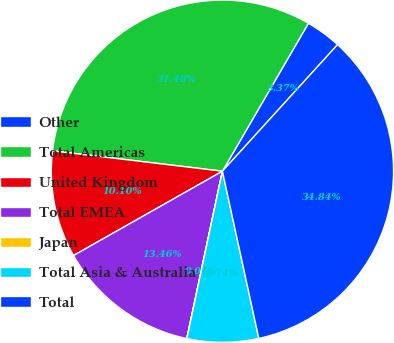Convert chart. <chart><loc_0><loc_0><loc_500><loc_500><pie_chart><fcel>Other<fcel>Total Americas<fcel>United Kingdom<fcel>Total EMEA<fcel>Japan<fcel>Total Asia & Australia<fcel>Total<nl><fcel>3.37%<fcel>31.48%<fcel>10.1%<fcel>13.46%<fcel>0.01%<fcel>6.74%<fcel>34.84%<nl></chart> 